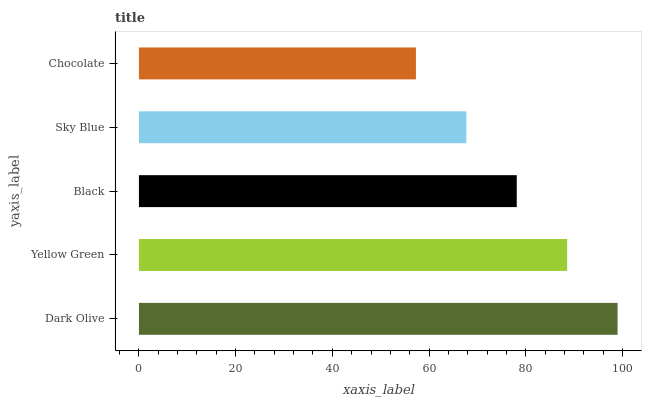Is Chocolate the minimum?
Answer yes or no. Yes. Is Dark Olive the maximum?
Answer yes or no. Yes. Is Yellow Green the minimum?
Answer yes or no. No. Is Yellow Green the maximum?
Answer yes or no. No. Is Dark Olive greater than Yellow Green?
Answer yes or no. Yes. Is Yellow Green less than Dark Olive?
Answer yes or no. Yes. Is Yellow Green greater than Dark Olive?
Answer yes or no. No. Is Dark Olive less than Yellow Green?
Answer yes or no. No. Is Black the high median?
Answer yes or no. Yes. Is Black the low median?
Answer yes or no. Yes. Is Yellow Green the high median?
Answer yes or no. No. Is Sky Blue the low median?
Answer yes or no. No. 